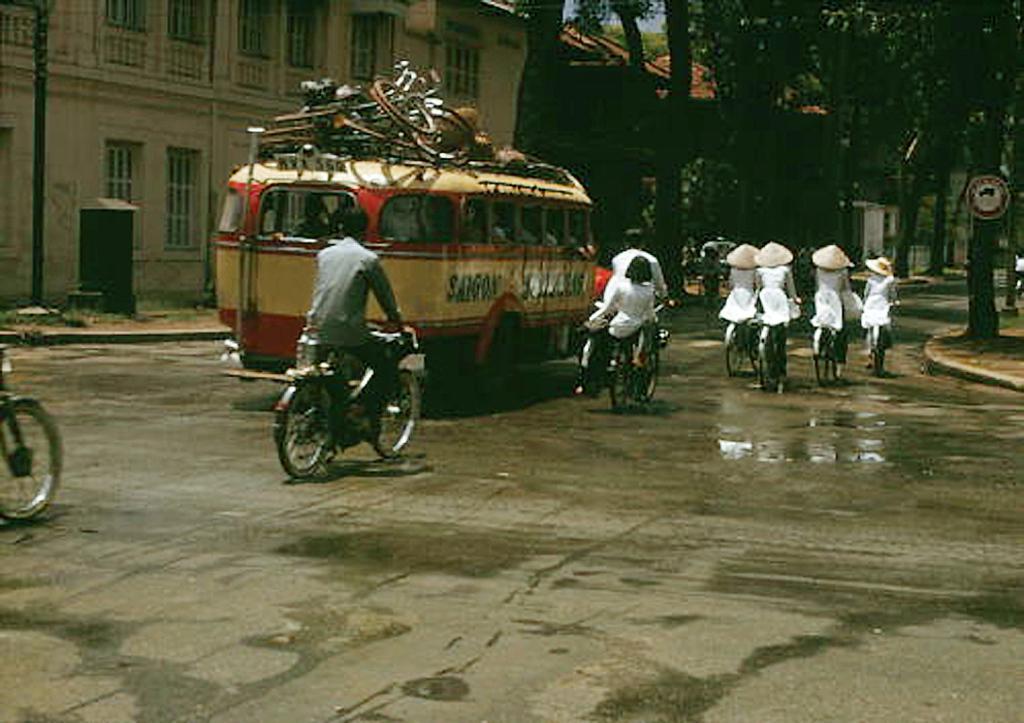How would you summarize this image in a sentence or two? In this image I can see few people riding bicycles and I can see few vehicles. In the background I can see few buildings, trees and the sky is in blue color. 